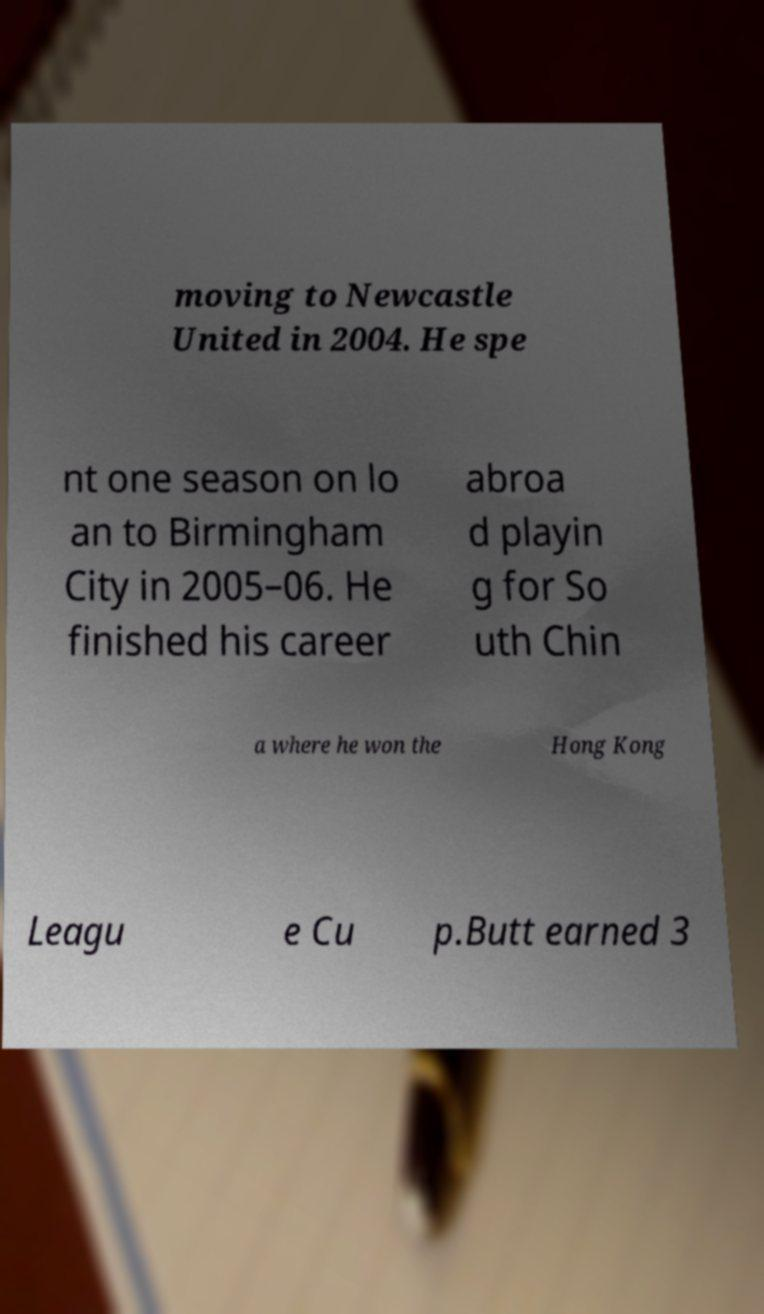For documentation purposes, I need the text within this image transcribed. Could you provide that? moving to Newcastle United in 2004. He spe nt one season on lo an to Birmingham City in 2005–06. He finished his career abroa d playin g for So uth Chin a where he won the Hong Kong Leagu e Cu p.Butt earned 3 